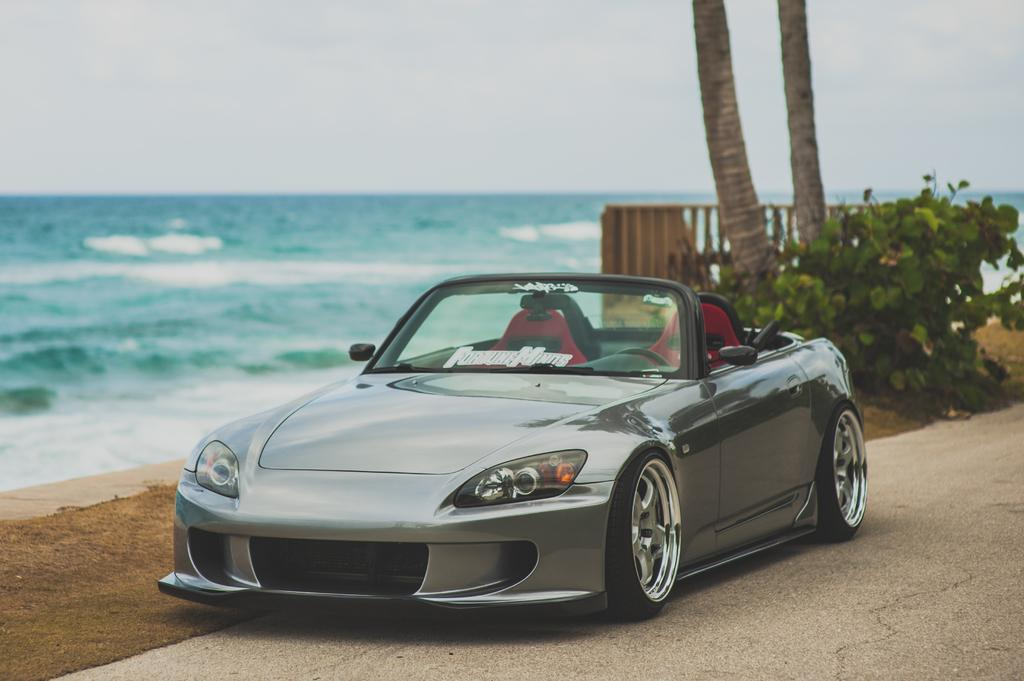What natural feature is present in the image? The image contains the sea. How many trees can be seen in the image? There are two trees in the image. What type of structure is present in the image? There is a gate in the image. What type of vehicle is parked in the image? A car is parked on the road in the image. What type of vegetation is present in the image? There are plants and grass in the image. What is visible at the top of the image? The sky is visible at the top of the image. What type of card game is being played in the image? There is no card game present in the image. What type of pets can be seen in the image? There are no pets visible in the image. 